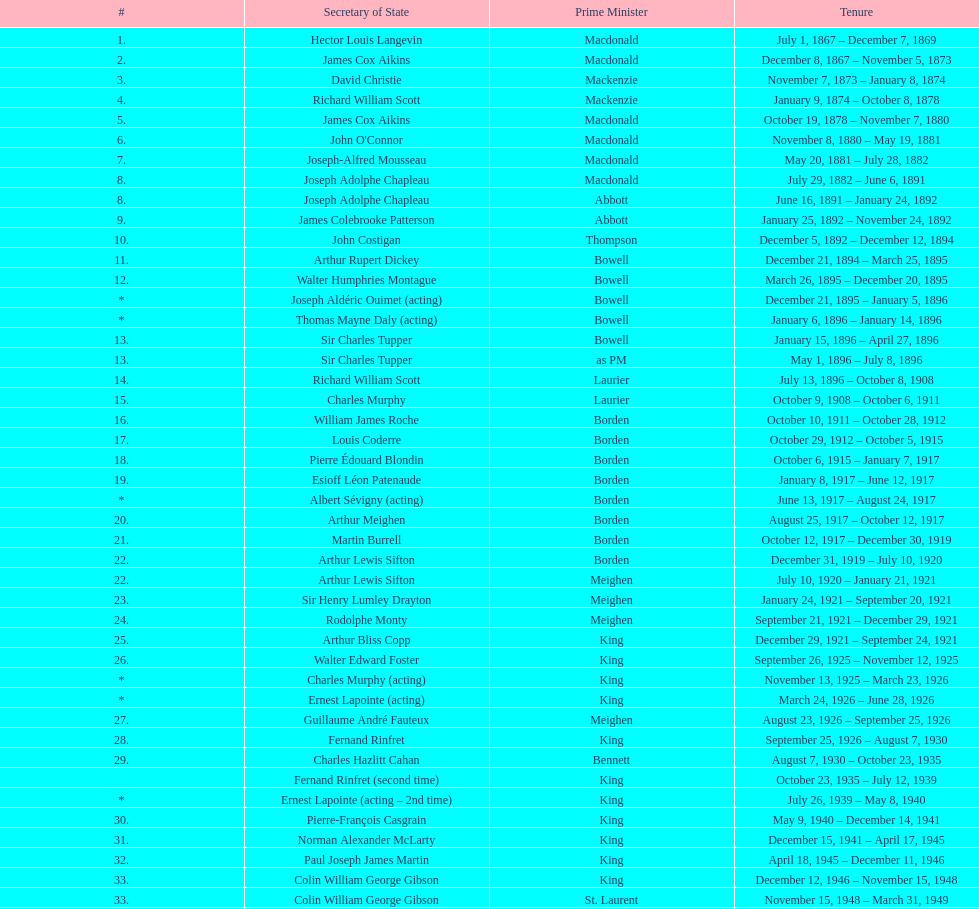Who was the secretary of state following jack pickersgill? Roch Pinard. 